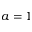<formula> <loc_0><loc_0><loc_500><loc_500>a = 1</formula> 